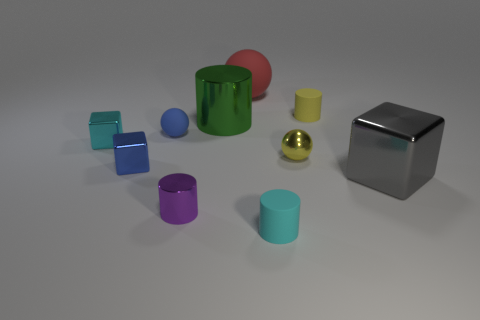There is a small thing that is the same color as the small shiny sphere; what is its shape?
Ensure brevity in your answer.  Cylinder. How many other objects are the same shape as the gray object?
Your answer should be compact. 2. Do the tiny matte sphere and the tiny block that is right of the small cyan cube have the same color?
Offer a very short reply. Yes. Is there anything else that has the same material as the red sphere?
Provide a short and direct response. Yes. What shape is the rubber object in front of the tiny cyan object that is behind the gray metal object?
Give a very brief answer. Cylinder. The shiny thing that is the same color as the tiny rubber ball is what size?
Provide a short and direct response. Small. There is a big object that is in front of the blue matte thing; is its shape the same as the large green object?
Ensure brevity in your answer.  No. Is the number of yellow rubber cylinders that are in front of the green cylinder greater than the number of large spheres left of the cyan shiny cube?
Offer a terse response. No. How many purple metal objects are behind the tiny purple cylinder left of the large red matte object?
Provide a succinct answer. 0. What is the material of the thing that is the same color as the metal ball?
Your response must be concise. Rubber. 